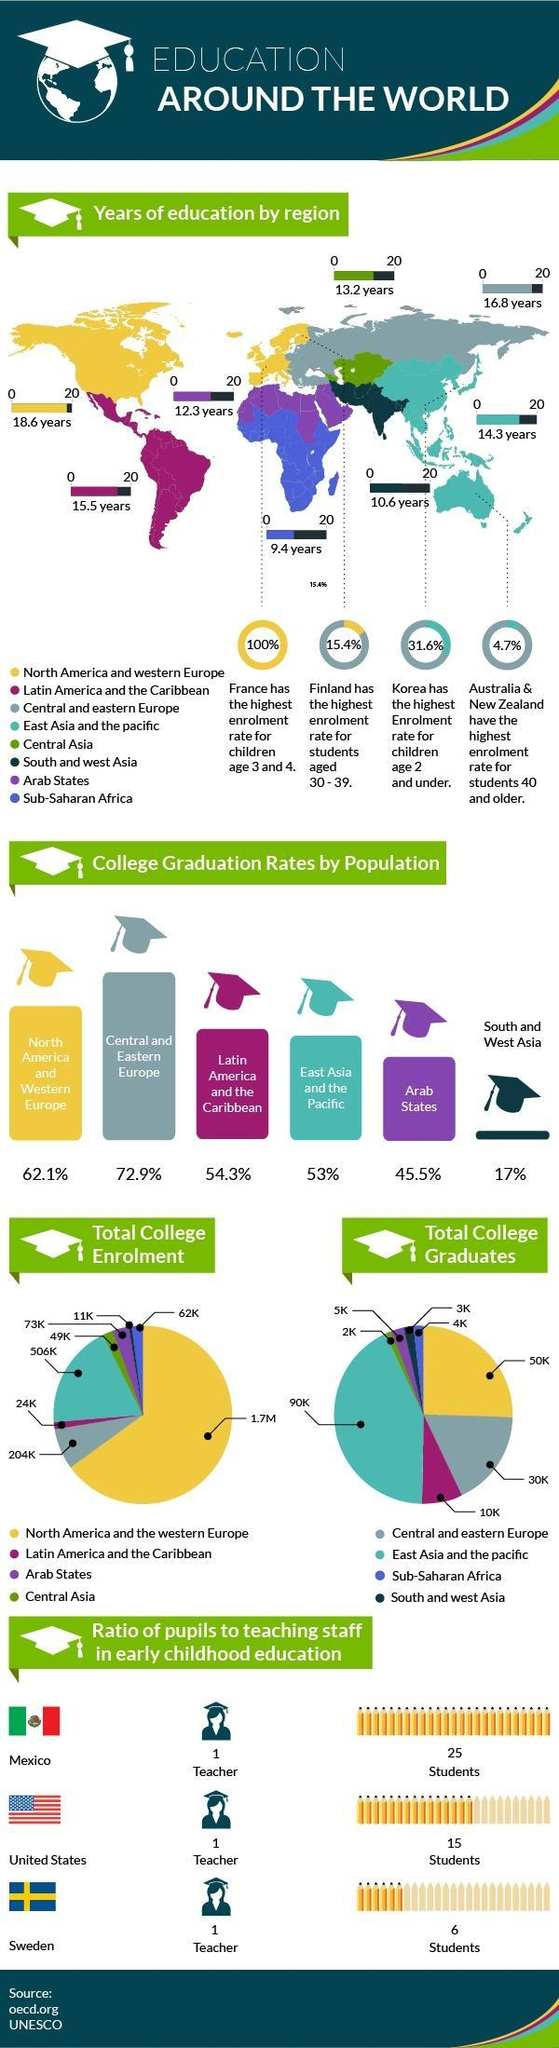What is the percentage of college graduation rates by population in Central and Eastern Europe?
Answer the question with a short phrase. 72.9% Which of these countries has the lowest teacher to students ratio - Mexico, Sweden or United States? Mexico How much is the years of education by region for south and west Asia? 10.6 years What is the total number of college graduates in Latin America and the Caribbean? 10K What is the total number of college graduates in Sub-Saharan Africa? 4K How much is the total college enrolment in East Asia and the Pacific? 506K What is the total college enrollment in North America and the western Europe? 1.7M Which country has highest enrolment rate for students in the age group 30-39? Finland What is the total number of college graduates in North America and western Europe? 50K What is the percentage of college graduation rates by population in South and west Asia? 17% 